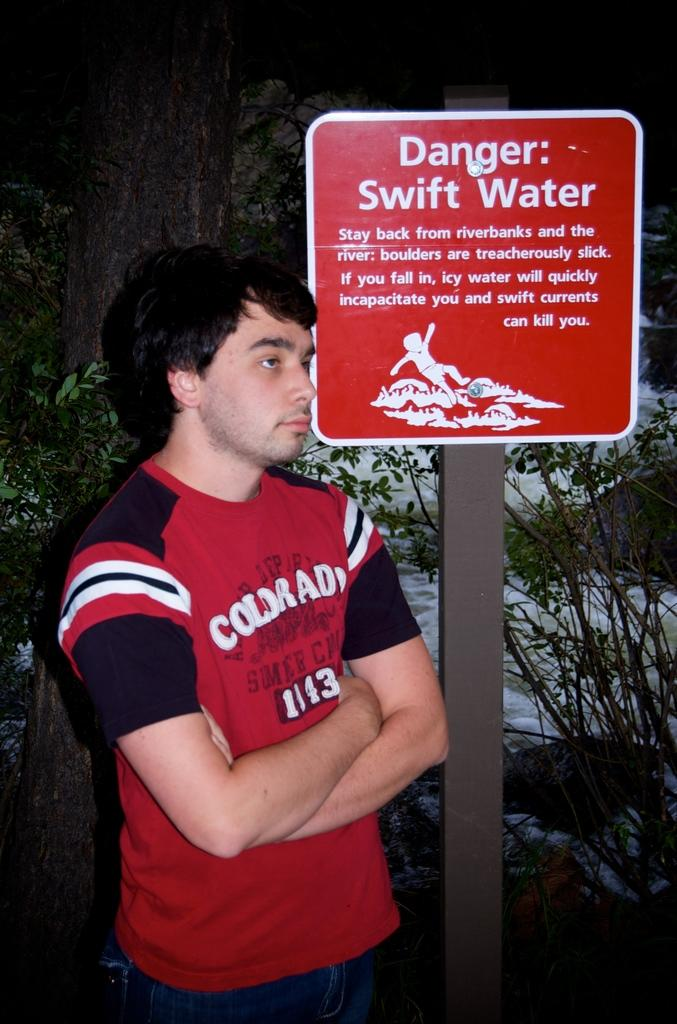<image>
Provide a brief description of the given image. a sign that says danger on the front of it 